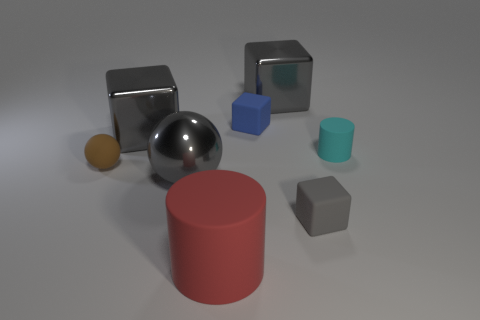How many other things are the same size as the red rubber thing? Observing the image, there appear to be three other objects that closely match the size of the red cylindrical object: the blue cube, the silver sphere, and the gray cube. 